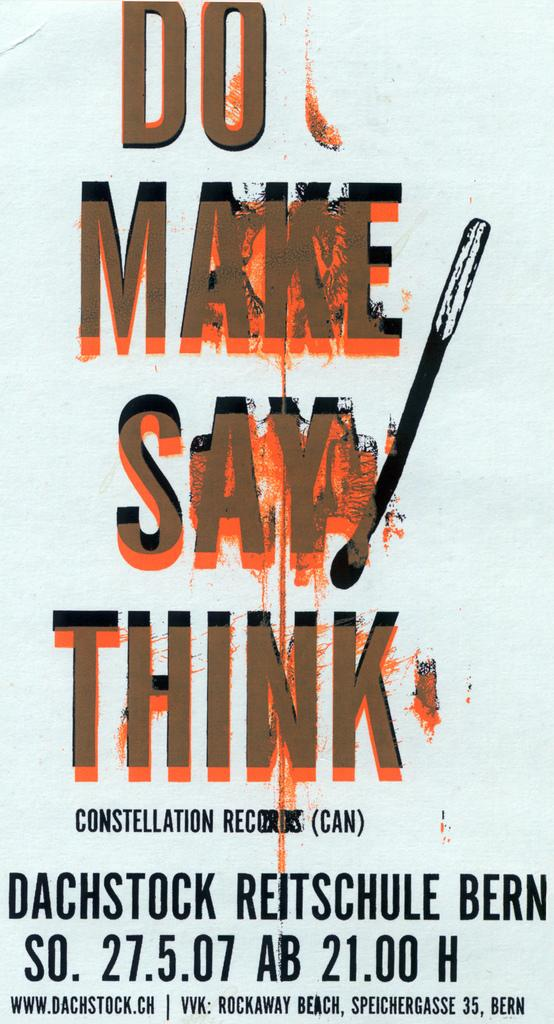What is the color of the poster in the image? The poster is white. What can be seen on the poster besides its color? There is edited text on the poster. Is there a woman holding a snake on the poster? There is no woman or snake present on the poster; it only features edited text on a white background. 